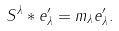<formula> <loc_0><loc_0><loc_500><loc_500>S ^ { \lambda } * e ^ { \prime } _ { \lambda } = m _ { \lambda } e ^ { \prime } _ { \lambda } .</formula> 